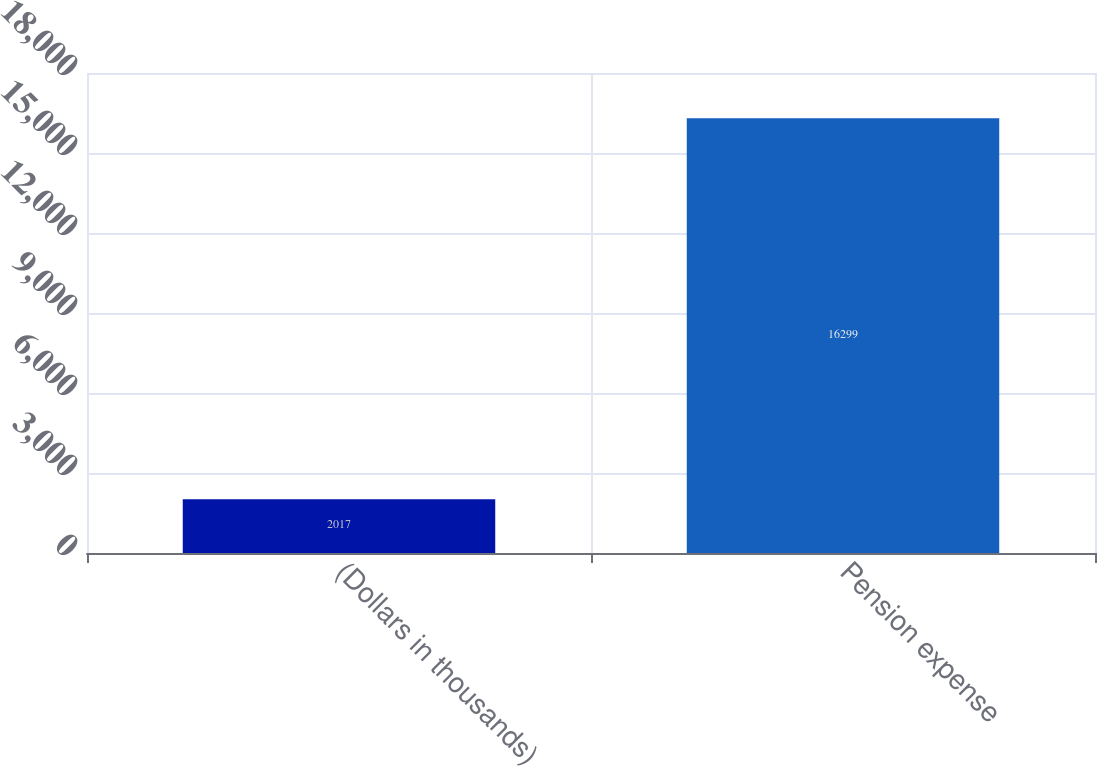<chart> <loc_0><loc_0><loc_500><loc_500><bar_chart><fcel>(Dollars in thousands)<fcel>Pension expense<nl><fcel>2017<fcel>16299<nl></chart> 